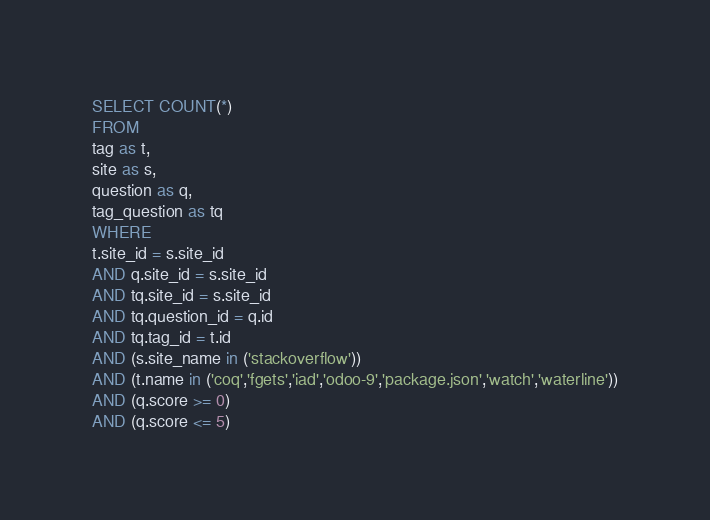<code> <loc_0><loc_0><loc_500><loc_500><_SQL_>SELECT COUNT(*)
FROM
tag as t,
site as s,
question as q,
tag_question as tq
WHERE
t.site_id = s.site_id
AND q.site_id = s.site_id
AND tq.site_id = s.site_id
AND tq.question_id = q.id
AND tq.tag_id = t.id
AND (s.site_name in ('stackoverflow'))
AND (t.name in ('coq','fgets','iad','odoo-9','package.json','watch','waterline'))
AND (q.score >= 0)
AND (q.score <= 5)
</code> 